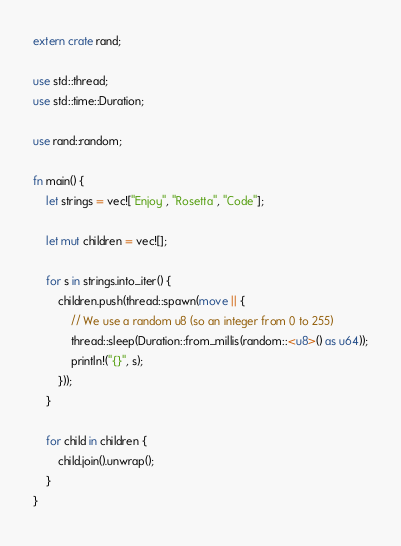<code> <loc_0><loc_0><loc_500><loc_500><_Rust_>extern crate rand;

use std::thread;
use std::time::Duration;

use rand::random;

fn main() {
    let strings = vec!["Enjoy", "Rosetta", "Code"];

    let mut children = vec![];

    for s in strings.into_iter() {
        children.push(thread::spawn(move || {
            // We use a random u8 (so an integer from 0 to 255)
            thread::sleep(Duration::from_millis(random::<u8>() as u64));
            println!("{}", s);
        }));
    }

    for child in children {
        child.join().unwrap();
    }
}
</code> 